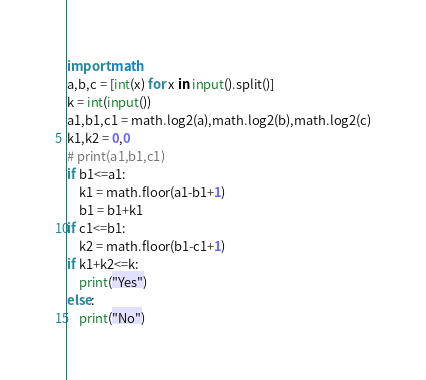<code> <loc_0><loc_0><loc_500><loc_500><_Python_>import math
a,b,c = [int(x) for x in input().split()]
k = int(input())
a1,b1,c1 = math.log2(a),math.log2(b),math.log2(c)
k1,k2 = 0,0
# print(a1,b1,c1)
if b1<=a1:
    k1 = math.floor(a1-b1+1)
    b1 = b1+k1
if c1<=b1:
    k2 = math.floor(b1-c1+1)
if k1+k2<=k:
    print("Yes")
else:
    print("No")</code> 